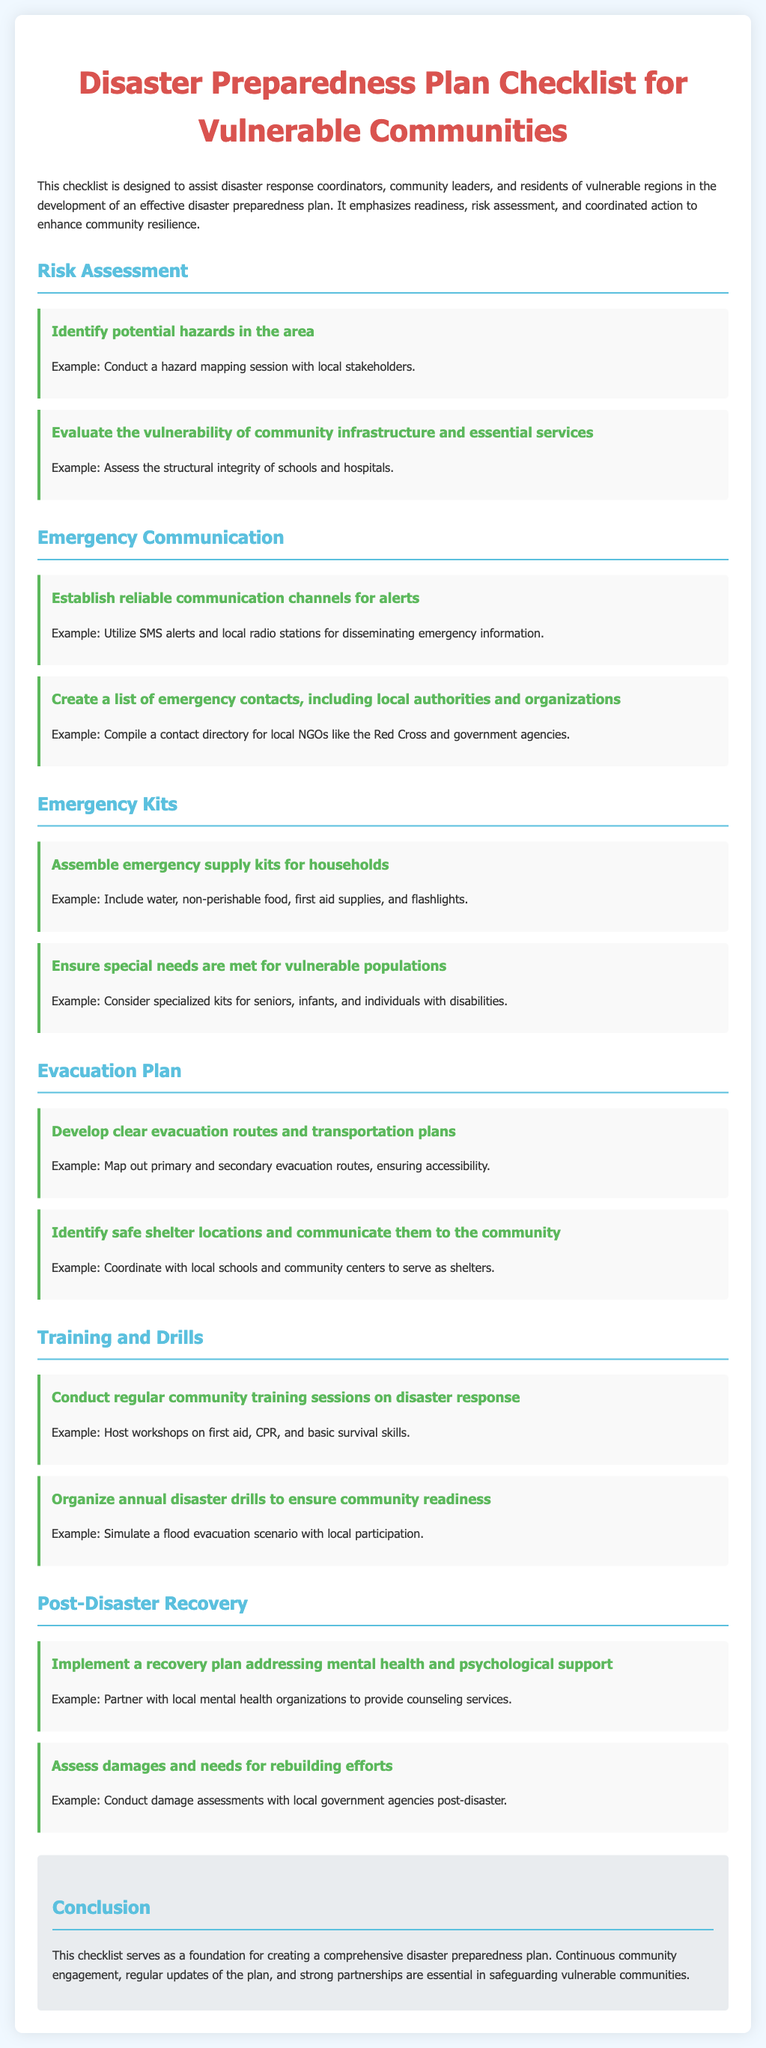What is the title of the document? The title is located at the top of the document and states the purpose of the content.
Answer: Disaster Preparedness Plan Checklist for Vulnerable Communities What is one example of a potential hazard identification method? The example is provided in the risk assessment section under potential hazards.
Answer: Conduct a hazard mapping session with local stakeholders What should be included in emergency supply kits? The document lists several items that are essential for emergency supply kits.
Answer: Water, non-perishable food, first aid supplies, and flashlights What is a recommended communication channel for alerts? The checklist specifies different options for reliable communication in emergencies.
Answer: SMS alerts and local radio stations How often should community training sessions be conducted? This detail highlights the frequency of training for disaster response.
Answer: Regularly What are two types of locations identified for safe shelter? The document states categories of places that can serve as shelters during disasters.
Answer: Local schools and community centers What is one aspect of the post-disaster recovery plan? The content outlines key components that are crucial after a disaster occurs.
Answer: Implement a recovery plan addressing mental health and psychological support What example is given for an evacuation drill? The document provides a specific scenario to illustrate the need for drills.
Answer: Simulate a flood evacuation scenario with local participation 